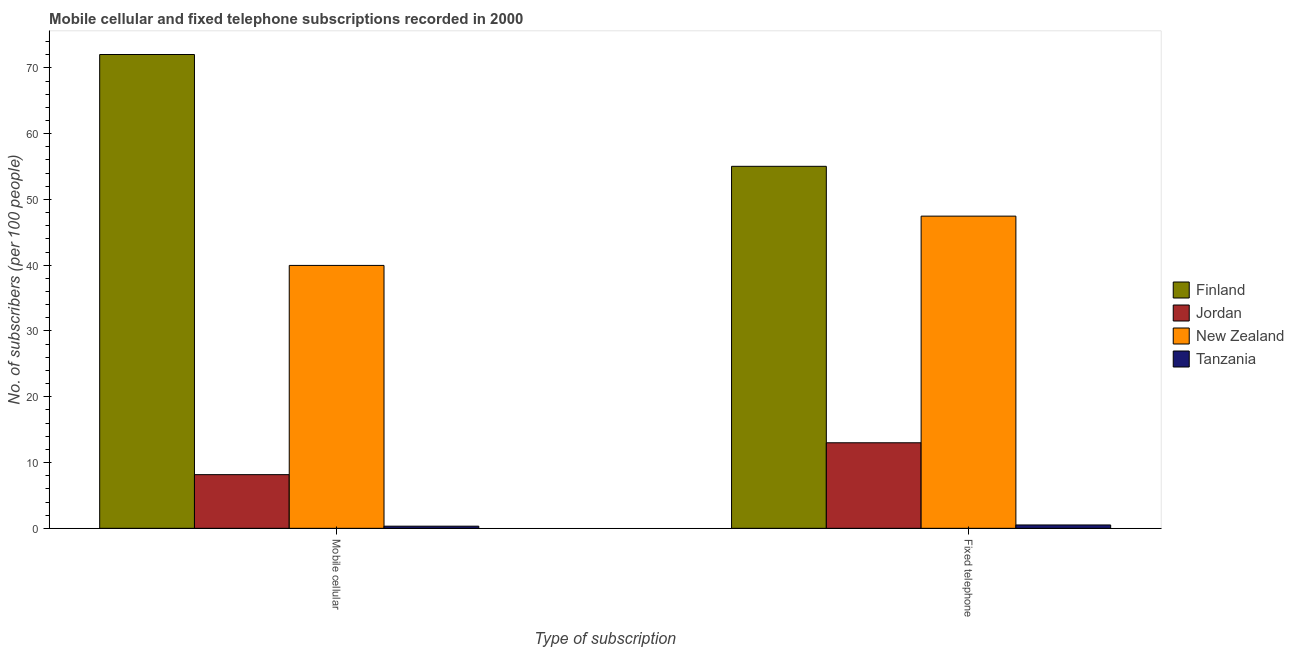Are the number of bars on each tick of the X-axis equal?
Your answer should be very brief. Yes. How many bars are there on the 1st tick from the left?
Your answer should be compact. 4. How many bars are there on the 1st tick from the right?
Your answer should be compact. 4. What is the label of the 2nd group of bars from the left?
Make the answer very short. Fixed telephone. What is the number of fixed telephone subscribers in Tanzania?
Keep it short and to the point. 0.51. Across all countries, what is the maximum number of fixed telephone subscribers?
Provide a short and direct response. 55.03. Across all countries, what is the minimum number of fixed telephone subscribers?
Make the answer very short. 0.51. In which country was the number of mobile cellular subscribers minimum?
Offer a terse response. Tanzania. What is the total number of mobile cellular subscribers in the graph?
Provide a short and direct response. 120.48. What is the difference between the number of mobile cellular subscribers in Tanzania and that in Jordan?
Provide a short and direct response. -7.83. What is the difference between the number of mobile cellular subscribers in New Zealand and the number of fixed telephone subscribers in Jordan?
Your answer should be very brief. 26.96. What is the average number of fixed telephone subscribers per country?
Your answer should be compact. 29. What is the difference between the number of fixed telephone subscribers and number of mobile cellular subscribers in Jordan?
Provide a short and direct response. 4.85. In how many countries, is the number of mobile cellular subscribers greater than 72 ?
Make the answer very short. 1. What is the ratio of the number of fixed telephone subscribers in Finland to that in New Zealand?
Your answer should be compact. 1.16. Is the number of mobile cellular subscribers in Tanzania less than that in Jordan?
Offer a terse response. Yes. In how many countries, is the number of fixed telephone subscribers greater than the average number of fixed telephone subscribers taken over all countries?
Offer a very short reply. 2. What does the 3rd bar from the left in Mobile cellular represents?
Offer a very short reply. New Zealand. What does the 1st bar from the right in Fixed telephone represents?
Make the answer very short. Tanzania. How many bars are there?
Your answer should be very brief. 8. How many countries are there in the graph?
Provide a short and direct response. 4. Does the graph contain any zero values?
Make the answer very short. No. Where does the legend appear in the graph?
Offer a very short reply. Center right. How many legend labels are there?
Provide a short and direct response. 4. How are the legend labels stacked?
Your answer should be very brief. Vertical. What is the title of the graph?
Keep it short and to the point. Mobile cellular and fixed telephone subscriptions recorded in 2000. Does "Faeroe Islands" appear as one of the legend labels in the graph?
Offer a very short reply. No. What is the label or title of the X-axis?
Make the answer very short. Type of subscription. What is the label or title of the Y-axis?
Offer a terse response. No. of subscribers (per 100 people). What is the No. of subscribers (per 100 people) of Finland in Mobile cellular?
Provide a succinct answer. 72.03. What is the No. of subscribers (per 100 people) in Jordan in Mobile cellular?
Your answer should be very brief. 8.16. What is the No. of subscribers (per 100 people) in New Zealand in Mobile cellular?
Give a very brief answer. 39.97. What is the No. of subscribers (per 100 people) of Tanzania in Mobile cellular?
Keep it short and to the point. 0.32. What is the No. of subscribers (per 100 people) of Finland in Fixed telephone?
Offer a terse response. 55.03. What is the No. of subscribers (per 100 people) of Jordan in Fixed telephone?
Your answer should be compact. 13. What is the No. of subscribers (per 100 people) of New Zealand in Fixed telephone?
Ensure brevity in your answer.  47.46. What is the No. of subscribers (per 100 people) in Tanzania in Fixed telephone?
Make the answer very short. 0.51. Across all Type of subscription, what is the maximum No. of subscribers (per 100 people) of Finland?
Make the answer very short. 72.03. Across all Type of subscription, what is the maximum No. of subscribers (per 100 people) of Jordan?
Your answer should be compact. 13. Across all Type of subscription, what is the maximum No. of subscribers (per 100 people) in New Zealand?
Give a very brief answer. 47.46. Across all Type of subscription, what is the maximum No. of subscribers (per 100 people) in Tanzania?
Your response must be concise. 0.51. Across all Type of subscription, what is the minimum No. of subscribers (per 100 people) of Finland?
Provide a succinct answer. 55.03. Across all Type of subscription, what is the minimum No. of subscribers (per 100 people) of Jordan?
Your answer should be compact. 8.16. Across all Type of subscription, what is the minimum No. of subscribers (per 100 people) of New Zealand?
Make the answer very short. 39.97. Across all Type of subscription, what is the minimum No. of subscribers (per 100 people) in Tanzania?
Ensure brevity in your answer.  0.32. What is the total No. of subscribers (per 100 people) in Finland in the graph?
Your response must be concise. 127.06. What is the total No. of subscribers (per 100 people) of Jordan in the graph?
Ensure brevity in your answer.  21.16. What is the total No. of subscribers (per 100 people) in New Zealand in the graph?
Provide a short and direct response. 87.43. What is the total No. of subscribers (per 100 people) of Tanzania in the graph?
Your answer should be very brief. 0.84. What is the difference between the No. of subscribers (per 100 people) in Finland in Mobile cellular and that in Fixed telephone?
Offer a very short reply. 17. What is the difference between the No. of subscribers (per 100 people) of Jordan in Mobile cellular and that in Fixed telephone?
Give a very brief answer. -4.85. What is the difference between the No. of subscribers (per 100 people) of New Zealand in Mobile cellular and that in Fixed telephone?
Provide a short and direct response. -7.49. What is the difference between the No. of subscribers (per 100 people) in Tanzania in Mobile cellular and that in Fixed telephone?
Provide a short and direct response. -0.19. What is the difference between the No. of subscribers (per 100 people) in Finland in Mobile cellular and the No. of subscribers (per 100 people) in Jordan in Fixed telephone?
Ensure brevity in your answer.  59.03. What is the difference between the No. of subscribers (per 100 people) of Finland in Mobile cellular and the No. of subscribers (per 100 people) of New Zealand in Fixed telephone?
Provide a succinct answer. 24.57. What is the difference between the No. of subscribers (per 100 people) in Finland in Mobile cellular and the No. of subscribers (per 100 people) in Tanzania in Fixed telephone?
Provide a succinct answer. 71.52. What is the difference between the No. of subscribers (per 100 people) of Jordan in Mobile cellular and the No. of subscribers (per 100 people) of New Zealand in Fixed telephone?
Make the answer very short. -39.3. What is the difference between the No. of subscribers (per 100 people) of Jordan in Mobile cellular and the No. of subscribers (per 100 people) of Tanzania in Fixed telephone?
Offer a very short reply. 7.65. What is the difference between the No. of subscribers (per 100 people) of New Zealand in Mobile cellular and the No. of subscribers (per 100 people) of Tanzania in Fixed telephone?
Your answer should be very brief. 39.46. What is the average No. of subscribers (per 100 people) of Finland per Type of subscription?
Your answer should be very brief. 63.53. What is the average No. of subscribers (per 100 people) of Jordan per Type of subscription?
Your answer should be compact. 10.58. What is the average No. of subscribers (per 100 people) of New Zealand per Type of subscription?
Give a very brief answer. 43.71. What is the average No. of subscribers (per 100 people) of Tanzania per Type of subscription?
Keep it short and to the point. 0.42. What is the difference between the No. of subscribers (per 100 people) of Finland and No. of subscribers (per 100 people) of Jordan in Mobile cellular?
Provide a succinct answer. 63.87. What is the difference between the No. of subscribers (per 100 people) in Finland and No. of subscribers (per 100 people) in New Zealand in Mobile cellular?
Your answer should be very brief. 32.06. What is the difference between the No. of subscribers (per 100 people) of Finland and No. of subscribers (per 100 people) of Tanzania in Mobile cellular?
Provide a short and direct response. 71.71. What is the difference between the No. of subscribers (per 100 people) of Jordan and No. of subscribers (per 100 people) of New Zealand in Mobile cellular?
Your answer should be compact. -31.81. What is the difference between the No. of subscribers (per 100 people) of Jordan and No. of subscribers (per 100 people) of Tanzania in Mobile cellular?
Your response must be concise. 7.83. What is the difference between the No. of subscribers (per 100 people) of New Zealand and No. of subscribers (per 100 people) of Tanzania in Mobile cellular?
Keep it short and to the point. 39.64. What is the difference between the No. of subscribers (per 100 people) of Finland and No. of subscribers (per 100 people) of Jordan in Fixed telephone?
Your answer should be very brief. 42.03. What is the difference between the No. of subscribers (per 100 people) in Finland and No. of subscribers (per 100 people) in New Zealand in Fixed telephone?
Your response must be concise. 7.57. What is the difference between the No. of subscribers (per 100 people) in Finland and No. of subscribers (per 100 people) in Tanzania in Fixed telephone?
Give a very brief answer. 54.52. What is the difference between the No. of subscribers (per 100 people) of Jordan and No. of subscribers (per 100 people) of New Zealand in Fixed telephone?
Offer a terse response. -34.45. What is the difference between the No. of subscribers (per 100 people) of Jordan and No. of subscribers (per 100 people) of Tanzania in Fixed telephone?
Offer a very short reply. 12.49. What is the difference between the No. of subscribers (per 100 people) of New Zealand and No. of subscribers (per 100 people) of Tanzania in Fixed telephone?
Provide a short and direct response. 46.95. What is the ratio of the No. of subscribers (per 100 people) of Finland in Mobile cellular to that in Fixed telephone?
Offer a very short reply. 1.31. What is the ratio of the No. of subscribers (per 100 people) in Jordan in Mobile cellular to that in Fixed telephone?
Your answer should be compact. 0.63. What is the ratio of the No. of subscribers (per 100 people) in New Zealand in Mobile cellular to that in Fixed telephone?
Make the answer very short. 0.84. What is the ratio of the No. of subscribers (per 100 people) of Tanzania in Mobile cellular to that in Fixed telephone?
Ensure brevity in your answer.  0.64. What is the difference between the highest and the second highest No. of subscribers (per 100 people) in Finland?
Offer a very short reply. 17. What is the difference between the highest and the second highest No. of subscribers (per 100 people) of Jordan?
Offer a terse response. 4.85. What is the difference between the highest and the second highest No. of subscribers (per 100 people) in New Zealand?
Your answer should be compact. 7.49. What is the difference between the highest and the second highest No. of subscribers (per 100 people) of Tanzania?
Give a very brief answer. 0.19. What is the difference between the highest and the lowest No. of subscribers (per 100 people) in Finland?
Provide a succinct answer. 17. What is the difference between the highest and the lowest No. of subscribers (per 100 people) of Jordan?
Make the answer very short. 4.85. What is the difference between the highest and the lowest No. of subscribers (per 100 people) of New Zealand?
Keep it short and to the point. 7.49. What is the difference between the highest and the lowest No. of subscribers (per 100 people) of Tanzania?
Provide a short and direct response. 0.19. 